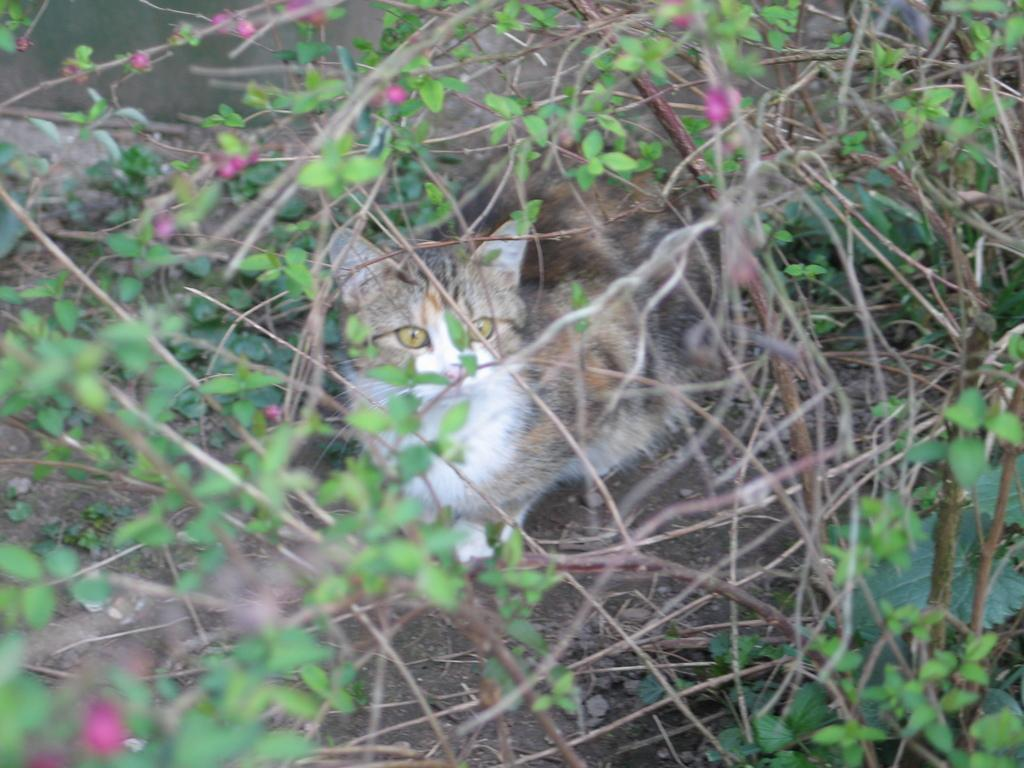What type of living organisms can be seen in the image? Plants can be seen in the image. Is there any animal present in the image? Yes, there is a cat under the plants in the image. What type of stew is the cat cooking in the image? There is no stew present in the image, nor is the cat shown cooking anything. 